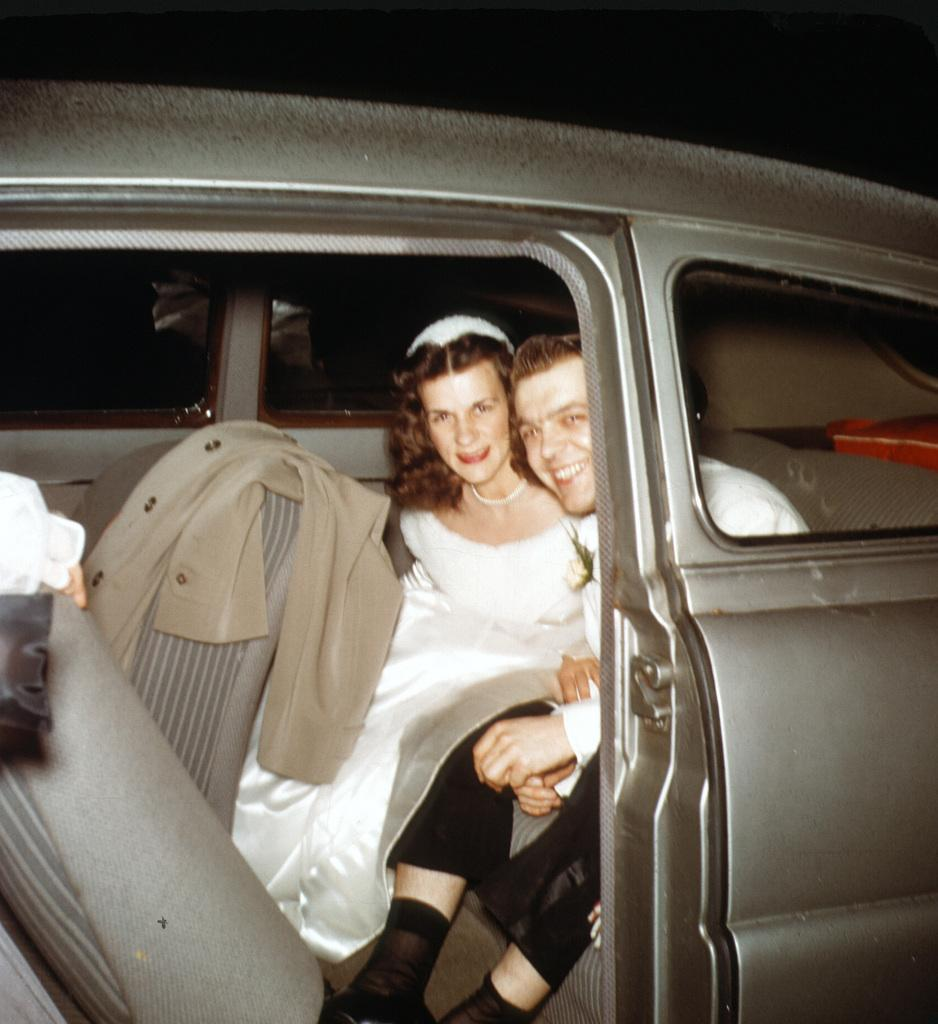Who is present in the image? There is a man and a woman in the image. What are the man and woman doing in the image? Both the man and woman are sitting in a car. What items can be seen in the image besides the man and woman? There is a jacket and a cloth in the image. What type of bridge can be seen in the image? There is no bridge present in the image. What hobbies do the man and woman share, as seen in the image? The image does not provide information about the man and woman's hobbies. 